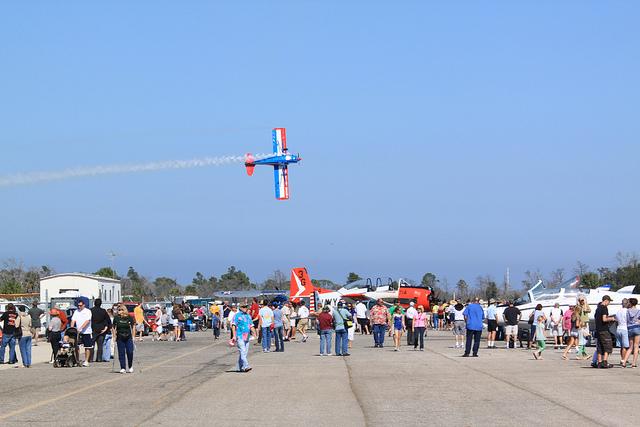What is the weather like?
Give a very brief answer. Clear. How many planes are in the sky?
Answer briefly. 1. Is there a baby been pulled?
Quick response, please. No. 